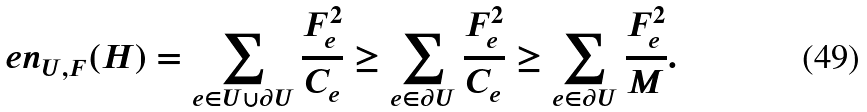<formula> <loc_0><loc_0><loc_500><loc_500>\ e n _ { U , F } ( H ) = \sum _ { e \in U \cup \partial U } { \frac { F _ { e } ^ { 2 } } { C _ { e } } } \geq \sum _ { e \in \partial U } { \frac { F _ { e } ^ { 2 } } { C _ { e } } } \geq \sum _ { e \in \partial U } { \frac { F _ { e } ^ { 2 } } { M } } .</formula> 